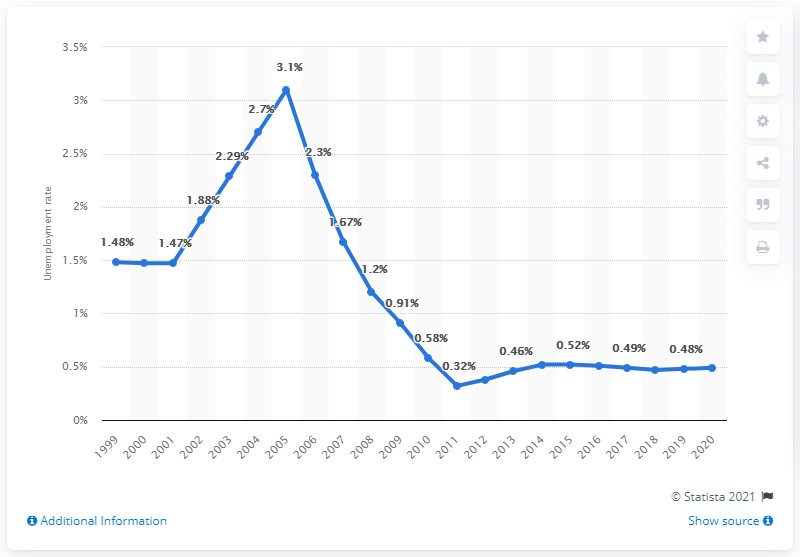Outline some significant characteristics in this image. In 2020, the unemployment rate in Niger was 0.49%. 